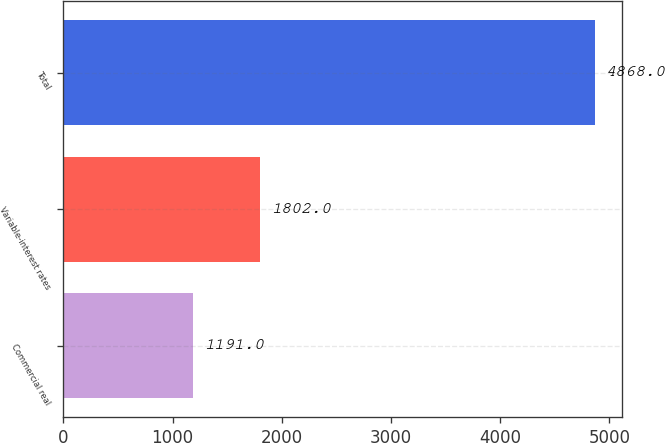Convert chart. <chart><loc_0><loc_0><loc_500><loc_500><bar_chart><fcel>Commercial real<fcel>Variable-interest rates<fcel>Total<nl><fcel>1191<fcel>1802<fcel>4868<nl></chart> 